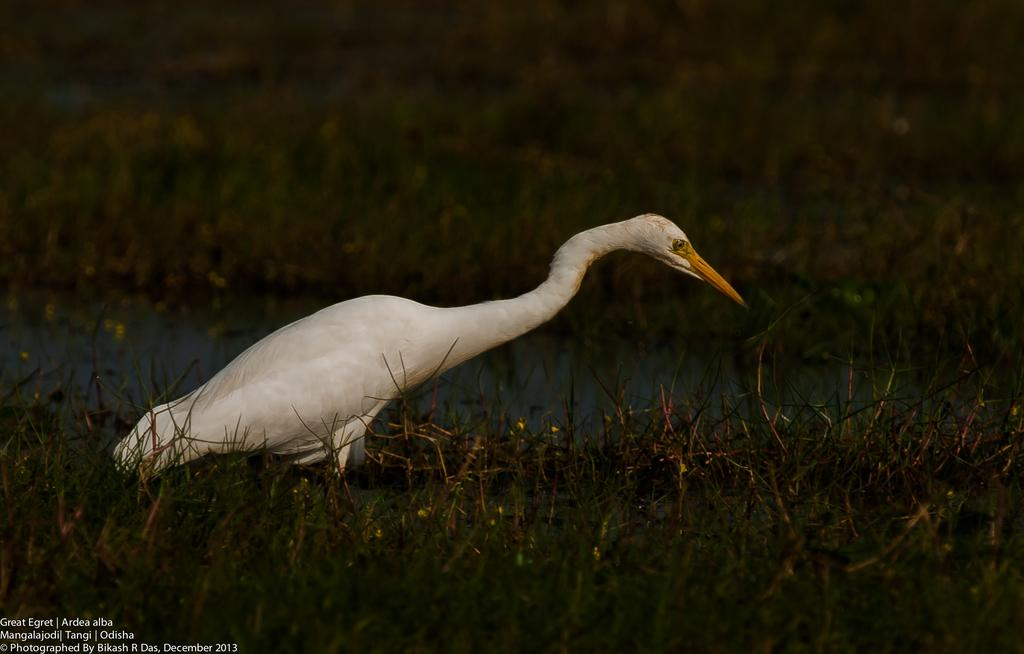What is the main subject in the water in the image? There is a crane standing in the water. What type of vegetation can be seen at the bottom of the image? There is grass at the bottom of the image. What is the primary element visible in the image? There is water visible in the image. Where is the text located in the image? The text is in the bottom left corner of the image. What type of smoke can be seen coming from the crane in the image? There is no smoke visible coming from the crane in the image. 